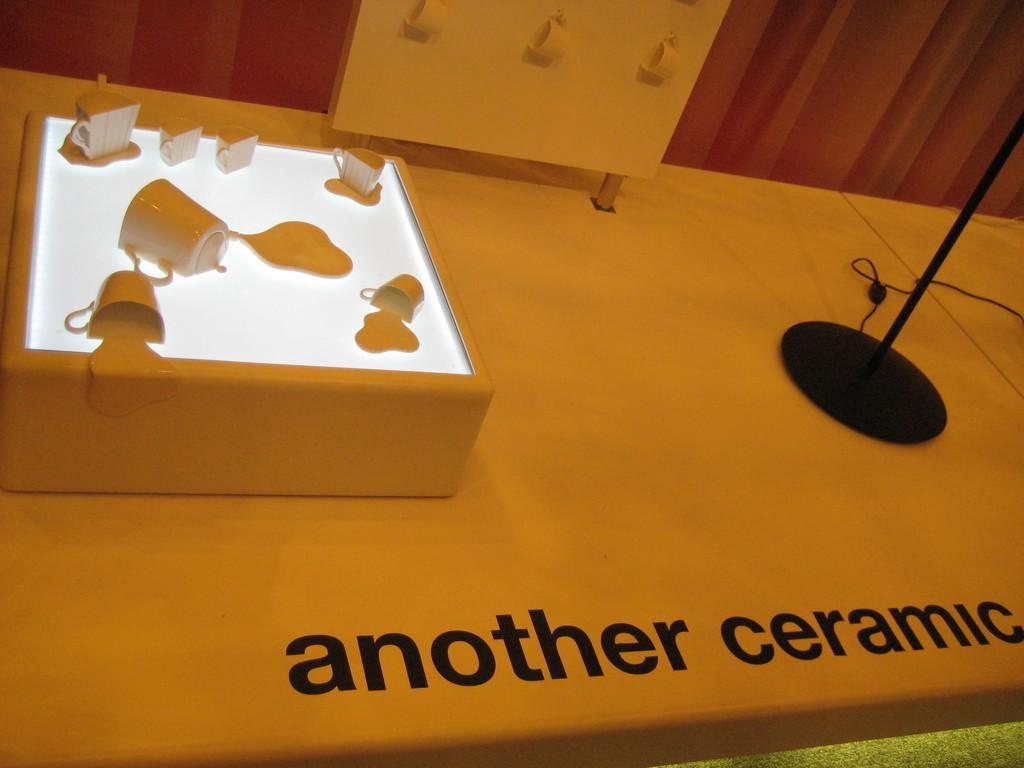<image>
Give a short and clear explanation of the subsequent image. A display of ceramic mugs is on a stage with the words another ceramic at the bottom. 